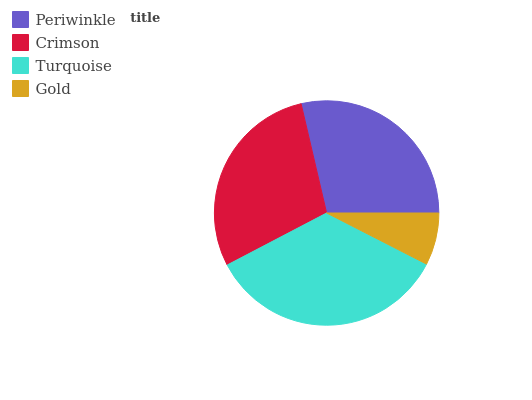Is Gold the minimum?
Answer yes or no. Yes. Is Turquoise the maximum?
Answer yes or no. Yes. Is Crimson the minimum?
Answer yes or no. No. Is Crimson the maximum?
Answer yes or no. No. Is Crimson greater than Periwinkle?
Answer yes or no. Yes. Is Periwinkle less than Crimson?
Answer yes or no. Yes. Is Periwinkle greater than Crimson?
Answer yes or no. No. Is Crimson less than Periwinkle?
Answer yes or no. No. Is Crimson the high median?
Answer yes or no. Yes. Is Periwinkle the low median?
Answer yes or no. Yes. Is Gold the high median?
Answer yes or no. No. Is Crimson the low median?
Answer yes or no. No. 